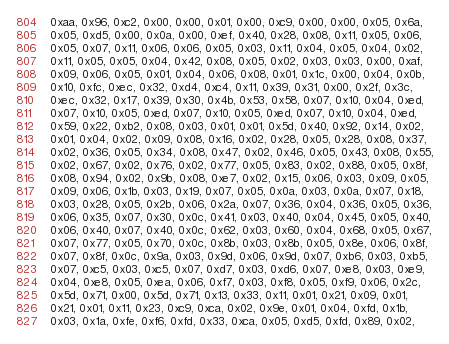Convert code to text. <code><loc_0><loc_0><loc_500><loc_500><_C_>  0xaa, 0x96, 0xc2, 0x00, 0x00, 0x01, 0x00, 0xc9, 0x00, 0x00, 0x05, 0x6a,
  0x05, 0xd5, 0x00, 0x0a, 0x00, 0xef, 0x40, 0x28, 0x08, 0x11, 0x05, 0x06,
  0x05, 0x07, 0x11, 0x06, 0x06, 0x05, 0x03, 0x11, 0x04, 0x05, 0x04, 0x02,
  0x11, 0x05, 0x05, 0x04, 0x42, 0x08, 0x05, 0x02, 0x03, 0x03, 0x00, 0xaf,
  0x09, 0x06, 0x05, 0x01, 0x04, 0x06, 0x08, 0x01, 0x1c, 0x00, 0x04, 0x0b,
  0x10, 0xfc, 0xec, 0x32, 0xd4, 0xc4, 0x11, 0x39, 0x31, 0x00, 0x2f, 0x3c,
  0xec, 0x32, 0x17, 0x39, 0x30, 0x4b, 0x53, 0x58, 0x07, 0x10, 0x04, 0xed,
  0x07, 0x10, 0x05, 0xed, 0x07, 0x10, 0x05, 0xed, 0x07, 0x10, 0x04, 0xed,
  0x59, 0x22, 0xb2, 0x08, 0x03, 0x01, 0x01, 0x5d, 0x40, 0x92, 0x14, 0x02,
  0x01, 0x04, 0x02, 0x09, 0x08, 0x16, 0x02, 0x28, 0x05, 0x28, 0x08, 0x37,
  0x02, 0x36, 0x05, 0x34, 0x08, 0x47, 0x02, 0x46, 0x05, 0x43, 0x08, 0x55,
  0x02, 0x67, 0x02, 0x76, 0x02, 0x77, 0x05, 0x83, 0x02, 0x88, 0x05, 0x8f,
  0x08, 0x94, 0x02, 0x9b, 0x08, 0xe7, 0x02, 0x15, 0x06, 0x03, 0x09, 0x05,
  0x09, 0x06, 0x1b, 0x03, 0x19, 0x07, 0x05, 0x0a, 0x03, 0x0a, 0x07, 0x18,
  0x03, 0x28, 0x05, 0x2b, 0x06, 0x2a, 0x07, 0x36, 0x04, 0x36, 0x05, 0x36,
  0x06, 0x35, 0x07, 0x30, 0x0c, 0x41, 0x03, 0x40, 0x04, 0x45, 0x05, 0x40,
  0x06, 0x40, 0x07, 0x40, 0x0c, 0x62, 0x03, 0x60, 0x04, 0x68, 0x05, 0x67,
  0x07, 0x77, 0x05, 0x70, 0x0c, 0x8b, 0x03, 0x8b, 0x05, 0x8e, 0x06, 0x8f,
  0x07, 0x8f, 0x0c, 0x9a, 0x03, 0x9d, 0x06, 0x9d, 0x07, 0xb6, 0x03, 0xb5,
  0x07, 0xc5, 0x03, 0xc5, 0x07, 0xd7, 0x03, 0xd6, 0x07, 0xe8, 0x03, 0xe9,
  0x04, 0xe8, 0x05, 0xea, 0x06, 0xf7, 0x03, 0xf8, 0x05, 0xf9, 0x06, 0x2c,
  0x5d, 0x71, 0x00, 0x5d, 0x71, 0x13, 0x33, 0x11, 0x01, 0x21, 0x09, 0x01,
  0x21, 0x01, 0x11, 0x23, 0xc9, 0xca, 0x02, 0x9e, 0x01, 0x04, 0xfd, 0x1b,
  0x03, 0x1a, 0xfe, 0xf6, 0xfd, 0x33, 0xca, 0x05, 0xd5, 0xfd, 0x89, 0x02,</code> 